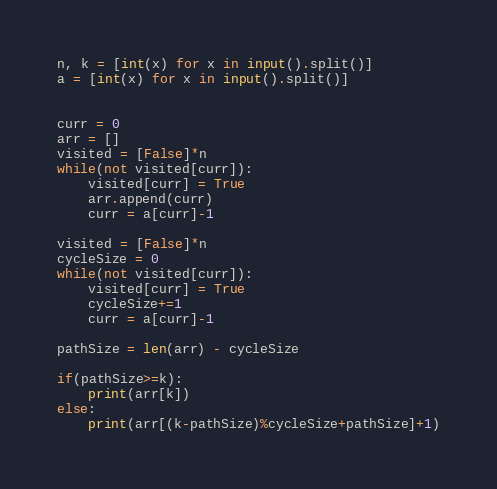<code> <loc_0><loc_0><loc_500><loc_500><_Python_>n, k = [int(x) for x in input().split()]
a = [int(x) for x in input().split()]


curr = 0
arr = []
visited = [False]*n
while(not visited[curr]):
    visited[curr] = True
    arr.append(curr)
    curr = a[curr]-1

visited = [False]*n
cycleSize = 0
while(not visited[curr]):
    visited[curr] = True
    cycleSize+=1
    curr = a[curr]-1

pathSize = len(arr) - cycleSize

if(pathSize>=k):
    print(arr[k])
else:
    print(arr[(k-pathSize)%cycleSize+pathSize]+1)</code> 